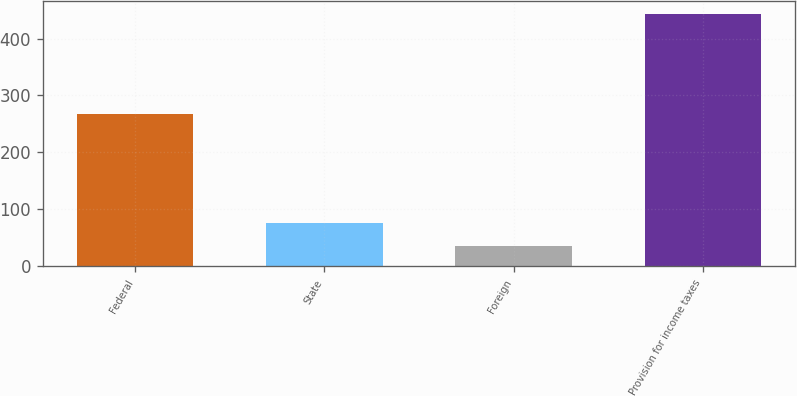Convert chart. <chart><loc_0><loc_0><loc_500><loc_500><bar_chart><fcel>Federal<fcel>State<fcel>Foreign<fcel>Provision for income taxes<nl><fcel>268<fcel>76.7<fcel>36<fcel>443<nl></chart> 